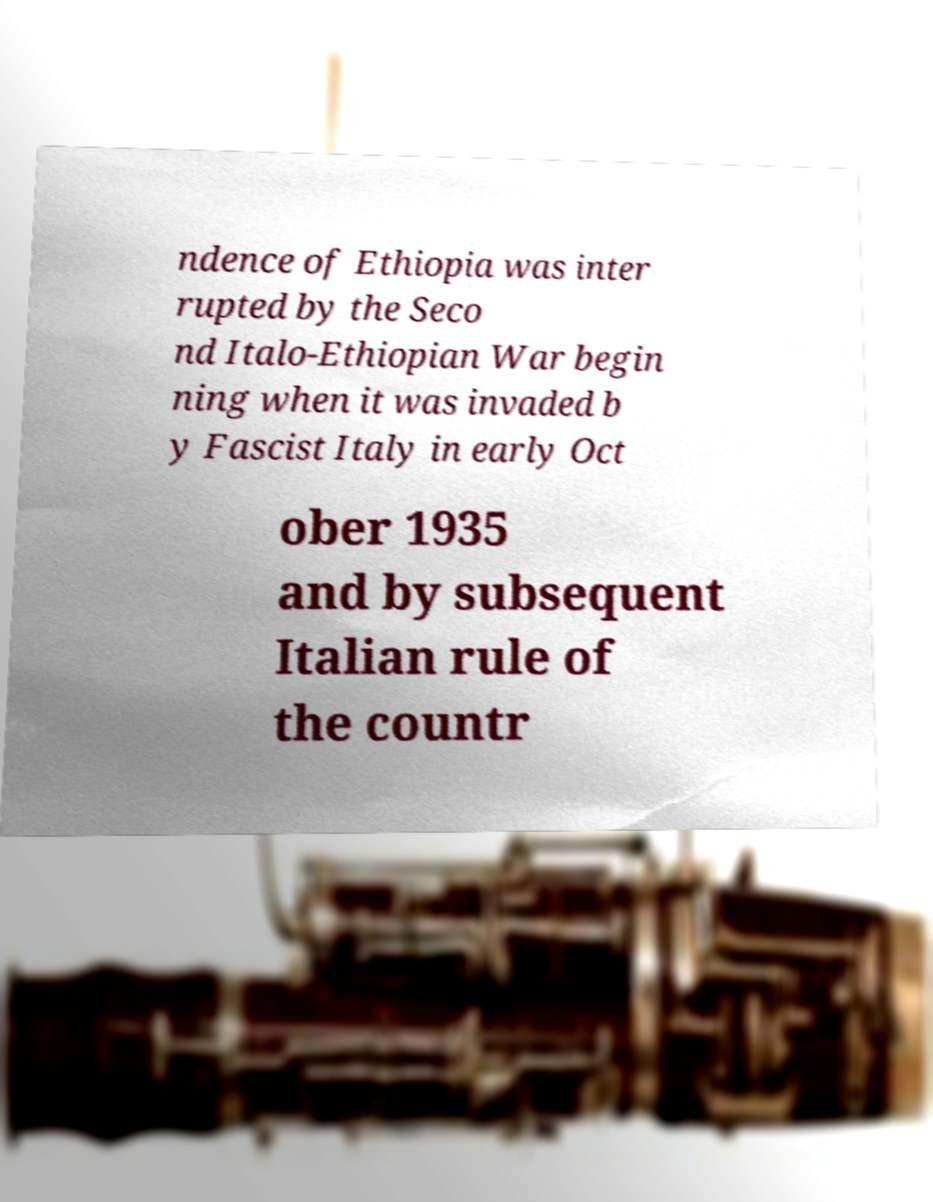I need the written content from this picture converted into text. Can you do that? ndence of Ethiopia was inter rupted by the Seco nd Italo-Ethiopian War begin ning when it was invaded b y Fascist Italy in early Oct ober 1935 and by subsequent Italian rule of the countr 